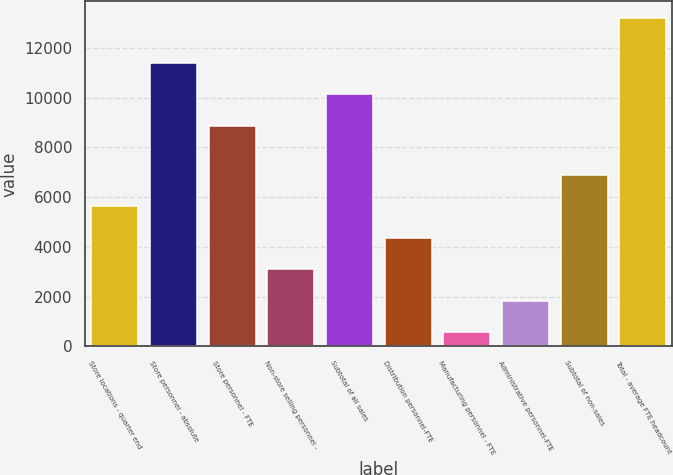Convert chart. <chart><loc_0><loc_0><loc_500><loc_500><bar_chart><fcel>Store locations - quarter end<fcel>Store personnel - absolute<fcel>Store personnel - FTE<fcel>Non-store selling personnel -<fcel>Subtotal of all sales<fcel>Distribution personnel-FTE<fcel>Manufacturing personnel - FTE<fcel>Administrative personnel-FTE<fcel>Subtotal of non-sales<fcel>Total - average FTE headcount<nl><fcel>5623.8<fcel>11404.4<fcel>8875<fcel>3094.4<fcel>10139.7<fcel>4359.1<fcel>565<fcel>1829.7<fcel>6888.5<fcel>13212<nl></chart> 